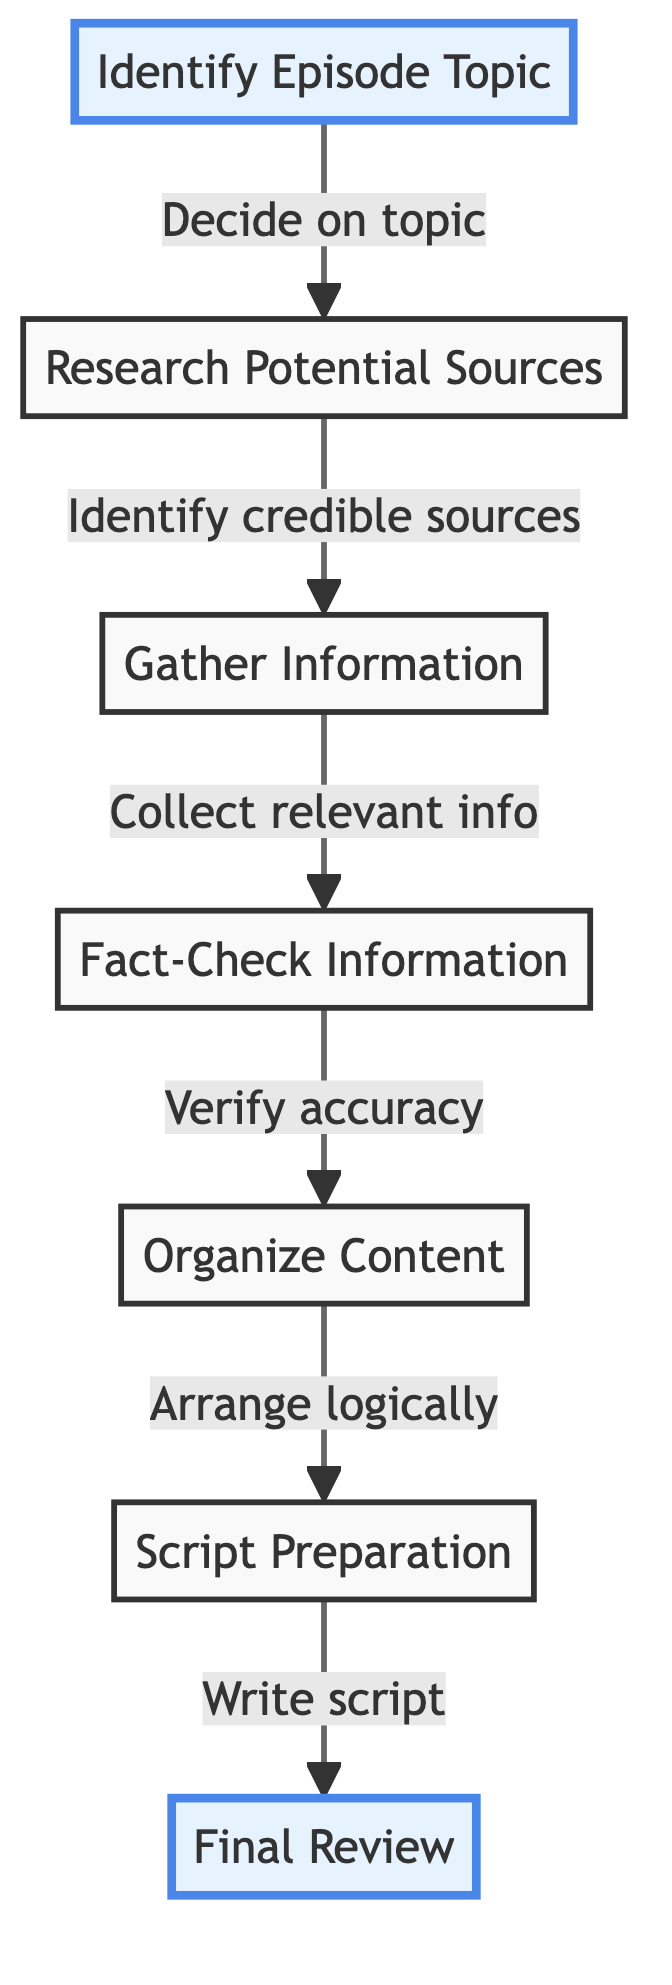What is the first step in the episode research process? The diagram indicates that the first step is to "Identify Episode Topic," which is depicted as the initial node in the flow.
Answer: Identify Episode Topic How many nodes are in this diagram? By counting each distinct step or element from "Identify Episode Topic" to "Final Review," we find there are a total of 7 nodes represented in the flowchart.
Answer: 7 What step follows "Fact-Check Information"? The arrow directed from the "Fact-Check Information" node leads directly to the "Organize Content" node, showing the flow of the process.
Answer: Organize Content Which two steps are highlighted in the diagram? The nodes "Identify Episode Topic" and "Final Review" are specifically highlighted, indicating significant points in the process.
Answer: Identify Episode Topic, Final Review What does the "Gather Information" step involve? The diagram states that this step includes "Collect relevant info," which refers to the action taken at this stage of the research process.
Answer: Collect relevant info How does the "Script Preparation" relate to "Organize Content"? The "Script Preparation" node is directly connected to "Organize Content," indicating that the script is written based on the content structured earlier in the process.
Answer: Write script In which step is the accuracy of information verified? According to the flow of the diagram, the accuracy of the information is verified during the "Fact-Check Information" step, where cross-referencing is performed.
Answer: Fact-Check Information What is the final action in the episode research process? The last action depicted in the diagram is the "Final Review" step, which involves conducting a thorough review of the script.
Answer: Final Review What is the relationship between "Research Potential Sources" and "Gather Information"? The diagram shows a directional arrow from "Research Potential Sources" to "Gather Information," indicating that researching sources leads directly to gathering information.
Answer: Research leads to gather information 